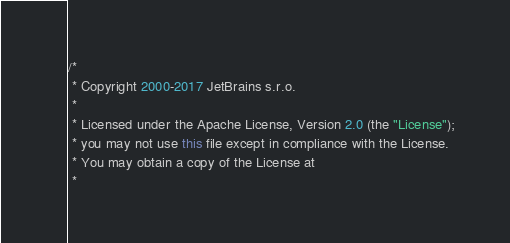Convert code to text. <code><loc_0><loc_0><loc_500><loc_500><_Java_>/*
 * Copyright 2000-2017 JetBrains s.r.o.
 *
 * Licensed under the Apache License, Version 2.0 (the "License");
 * you may not use this file except in compliance with the License.
 * You may obtain a copy of the License at
 *</code> 